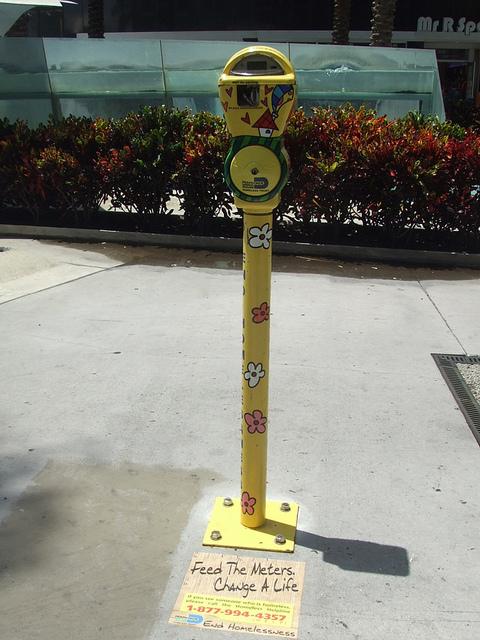What is along the road behind meter?
Write a very short answer. Bushes. What color is the meter?
Give a very brief answer. Yellow. What graphics are on the meter?
Be succinct. Flowers. 